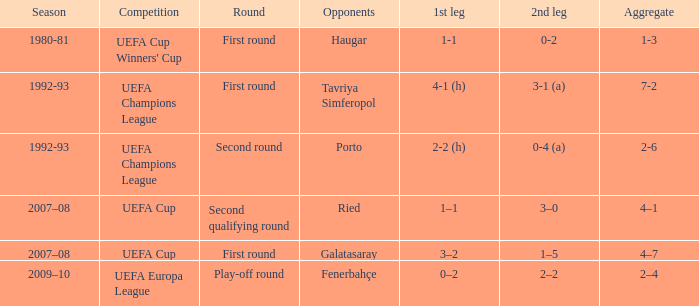 what's the competition where 1st leg is 4-1 (h) UEFA Champions League. 